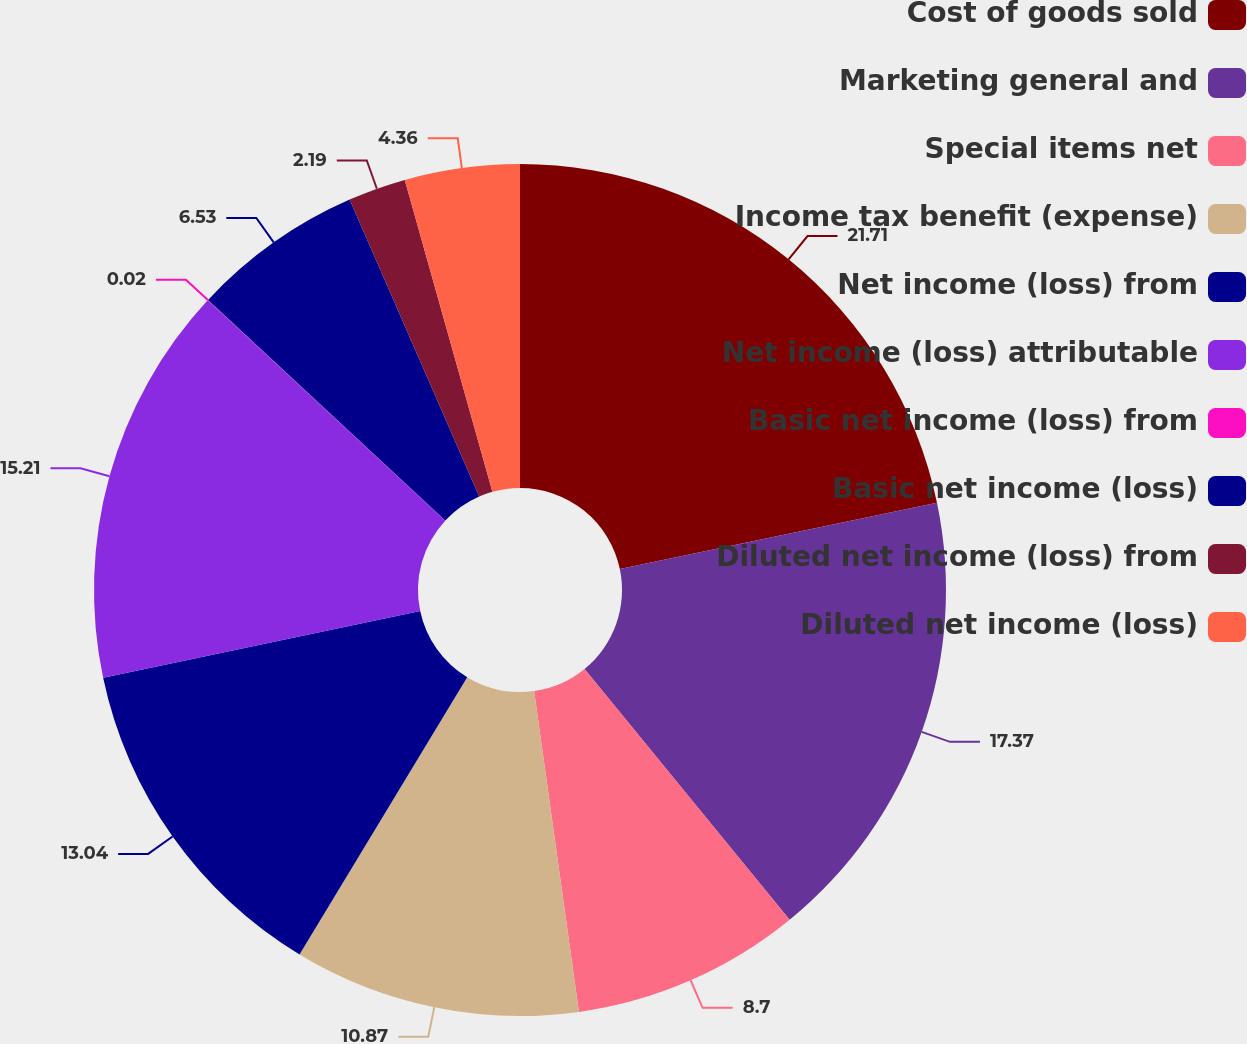Convert chart to OTSL. <chart><loc_0><loc_0><loc_500><loc_500><pie_chart><fcel>Cost of goods sold<fcel>Marketing general and<fcel>Special items net<fcel>Income tax benefit (expense)<fcel>Net income (loss) from<fcel>Net income (loss) attributable<fcel>Basic net income (loss) from<fcel>Basic net income (loss)<fcel>Diluted net income (loss) from<fcel>Diluted net income (loss)<nl><fcel>21.72%<fcel>17.38%<fcel>8.7%<fcel>10.87%<fcel>13.04%<fcel>15.21%<fcel>0.02%<fcel>6.53%<fcel>2.19%<fcel>4.36%<nl></chart> 